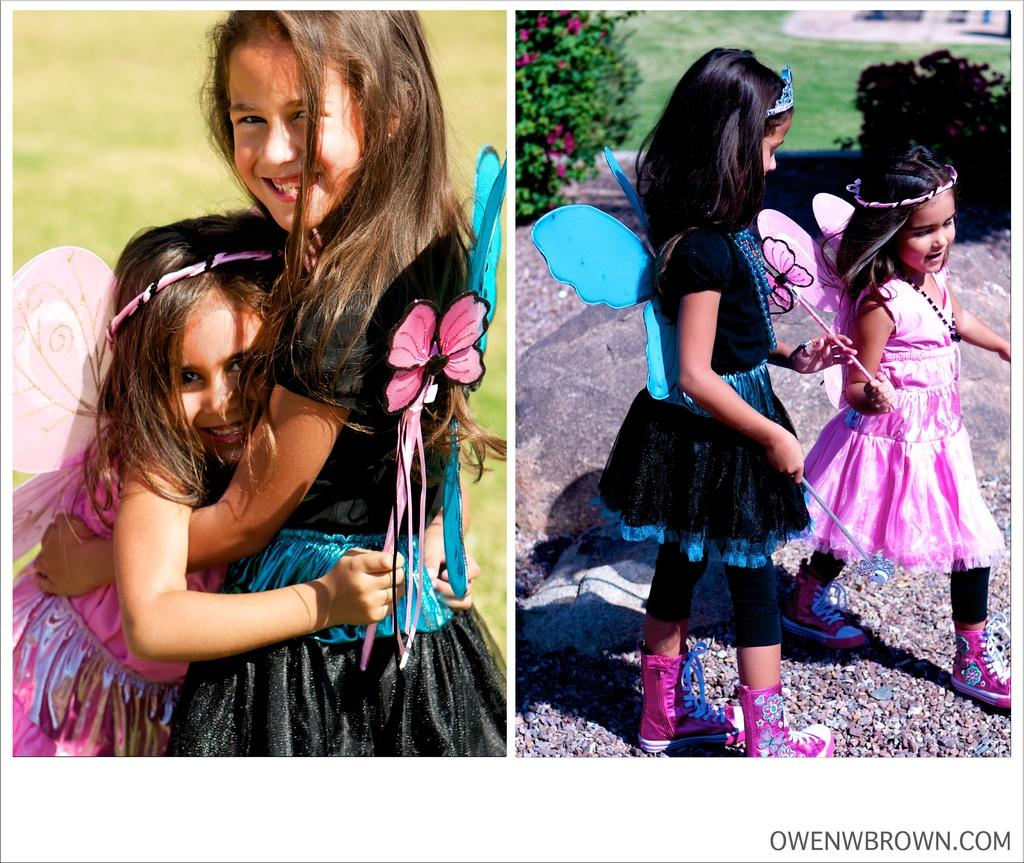What type of vegetation can be seen in the image? There is grass and plants in the image. How many people are present in the image? There are two people standing in the image. What is the rate at which the box is being carried by the two people in the image? There is no box present in the image, so it is not possible to determine the rate at which it might be carried. 